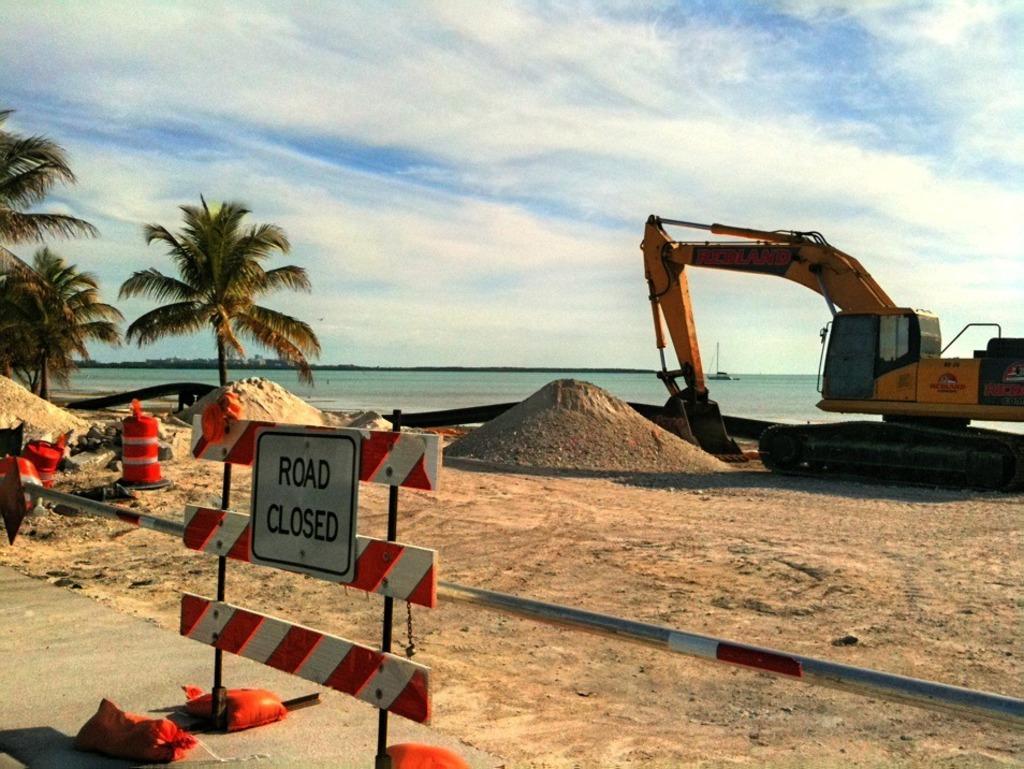Could you give a brief overview of what you see in this image? In this picture we can see a name board, pole, sand, trees, excavator on the ground, boat on the water and some objects and in the background we can see the sky with clouds. 